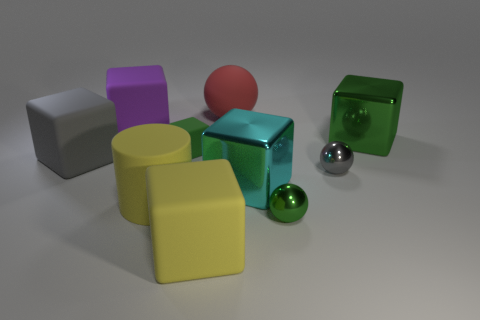There is a big thing that is the same color as the big cylinder; what shape is it?
Offer a terse response. Cube. There is a tiny thing that is the same color as the tiny matte cube; what is it made of?
Ensure brevity in your answer.  Metal. What number of objects are big yellow metal cylinders or tiny metal things?
Provide a short and direct response. 2. Are there any big matte blocks that have the same color as the tiny matte cube?
Keep it short and to the point. No. There is a metal object that is behind the gray cube; how many big red spheres are right of it?
Provide a short and direct response. 0. Are there more purple metallic cubes than green shiny cubes?
Offer a terse response. No. Are the red object and the big green block made of the same material?
Your response must be concise. No. Are there the same number of red balls that are in front of the cyan block and small green shiny things?
Offer a very short reply. No. What number of green things are made of the same material as the big sphere?
Offer a very short reply. 1. Are there fewer metallic objects than big green metal objects?
Offer a very short reply. No. 